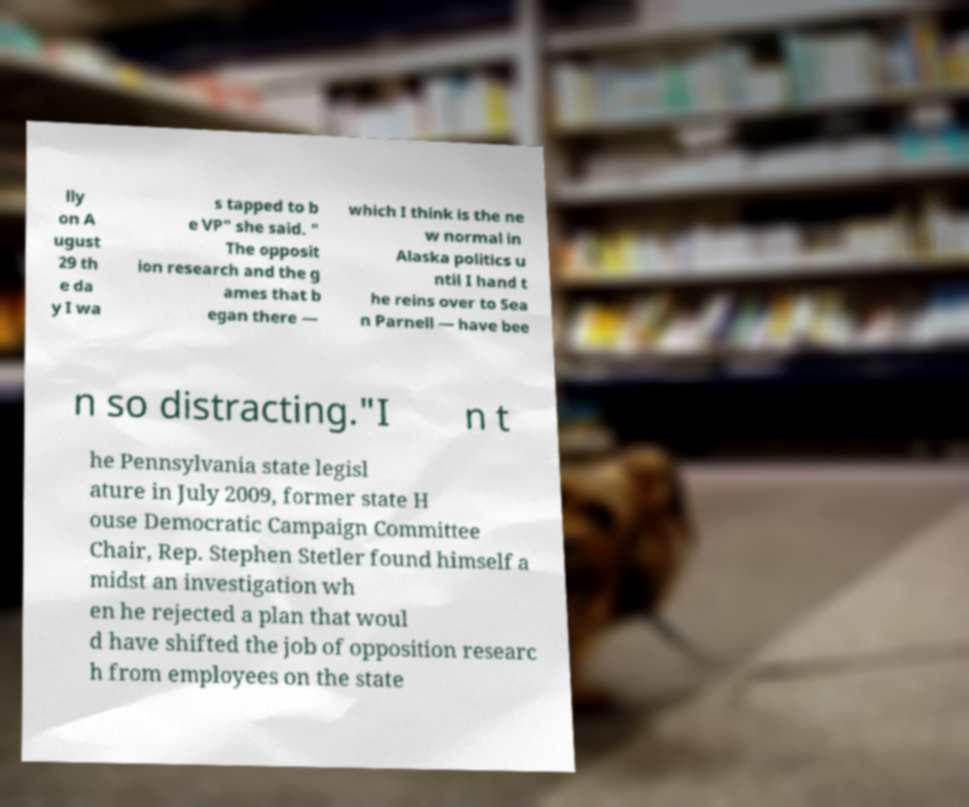Can you read and provide the text displayed in the image?This photo seems to have some interesting text. Can you extract and type it out for me? lly on A ugust 29 th e da y I wa s tapped to b e VP" she said. " The opposit ion research and the g ames that b egan there — which I think is the ne w normal in Alaska politics u ntil I hand t he reins over to Sea n Parnell — have bee n so distracting."I n t he Pennsylvania state legisl ature in July 2009, former state H ouse Democratic Campaign Committee Chair, Rep. Stephen Stetler found himself a midst an investigation wh en he rejected a plan that woul d have shifted the job of opposition researc h from employees on the state 